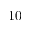Convert formula to latex. <formula><loc_0><loc_0><loc_500><loc_500>1 0</formula> 